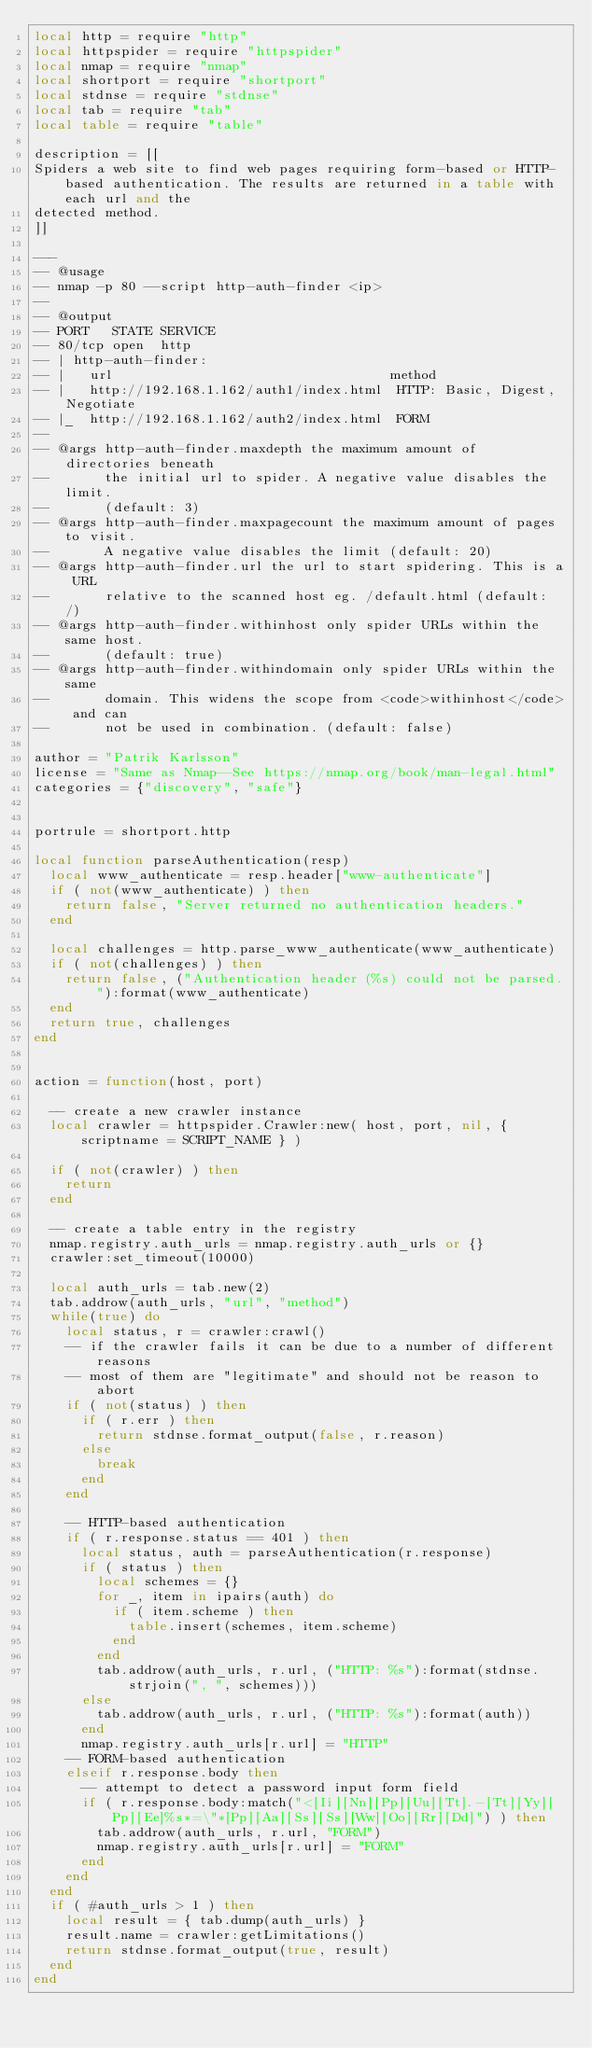<code> <loc_0><loc_0><loc_500><loc_500><_Lua_>local http = require "http"
local httpspider = require "httpspider"
local nmap = require "nmap"
local shortport = require "shortport"
local stdnse = require "stdnse"
local tab = require "tab"
local table = require "table"

description = [[
Spiders a web site to find web pages requiring form-based or HTTP-based authentication. The results are returned in a table with each url and the
detected method.
]]

---
-- @usage
-- nmap -p 80 --script http-auth-finder <ip>
--
-- @output
-- PORT   STATE SERVICE
-- 80/tcp open  http
-- | http-auth-finder:
-- |   url                                   method
-- |   http://192.168.1.162/auth1/index.html  HTTP: Basic, Digest, Negotiate
-- |_  http://192.168.1.162/auth2/index.html  FORM
--
-- @args http-auth-finder.maxdepth the maximum amount of directories beneath
--       the initial url to spider. A negative value disables the limit.
--       (default: 3)
-- @args http-auth-finder.maxpagecount the maximum amount of pages to visit.
--       A negative value disables the limit (default: 20)
-- @args http-auth-finder.url the url to start spidering. This is a URL
--       relative to the scanned host eg. /default.html (default: /)
-- @args http-auth-finder.withinhost only spider URLs within the same host.
--       (default: true)
-- @args http-auth-finder.withindomain only spider URLs within the same
--       domain. This widens the scope from <code>withinhost</code> and can
--       not be used in combination. (default: false)

author = "Patrik Karlsson"
license = "Same as Nmap--See https://nmap.org/book/man-legal.html"
categories = {"discovery", "safe"}


portrule = shortport.http

local function parseAuthentication(resp)
  local www_authenticate = resp.header["www-authenticate"]
  if ( not(www_authenticate) ) then
    return false, "Server returned no authentication headers."
  end

  local challenges = http.parse_www_authenticate(www_authenticate)
  if ( not(challenges) ) then
    return false, ("Authentication header (%s) could not be parsed."):format(www_authenticate)
  end
  return true, challenges
end


action = function(host, port)

  -- create a new crawler instance
  local crawler = httpspider.Crawler:new( host, port, nil, { scriptname = SCRIPT_NAME } )

  if ( not(crawler) ) then
    return
  end

  -- create a table entry in the registry
  nmap.registry.auth_urls = nmap.registry.auth_urls or {}
  crawler:set_timeout(10000)

  local auth_urls = tab.new(2)
  tab.addrow(auth_urls, "url", "method")
  while(true) do
    local status, r = crawler:crawl()
    -- if the crawler fails it can be due to a number of different reasons
    -- most of them are "legitimate" and should not be reason to abort
    if ( not(status) ) then
      if ( r.err ) then
        return stdnse.format_output(false, r.reason)
      else
        break
      end
    end

    -- HTTP-based authentication
    if ( r.response.status == 401 ) then
      local status, auth = parseAuthentication(r.response)
      if ( status ) then
        local schemes = {}
        for _, item in ipairs(auth) do
          if ( item.scheme ) then
            table.insert(schemes, item.scheme)
          end
        end
        tab.addrow(auth_urls, r.url, ("HTTP: %s"):format(stdnse.strjoin(", ", schemes)))
      else
        tab.addrow(auth_urls, r.url, ("HTTP: %s"):format(auth))
      end
      nmap.registry.auth_urls[r.url] = "HTTP"
    -- FORM-based authentication
    elseif r.response.body then
      -- attempt to detect a password input form field
      if ( r.response.body:match("<[Ii][Nn][Pp][Uu][Tt].-[Tt][Yy][Pp][Ee]%s*=\"*[Pp][Aa][Ss][Ss][Ww][Oo][Rr][Dd]") ) then
        tab.addrow(auth_urls, r.url, "FORM")
        nmap.registry.auth_urls[r.url] = "FORM"
      end
    end
  end
  if ( #auth_urls > 1 ) then
    local result = { tab.dump(auth_urls) }
    result.name = crawler:getLimitations()
    return stdnse.format_output(true, result)
  end
end
</code> 